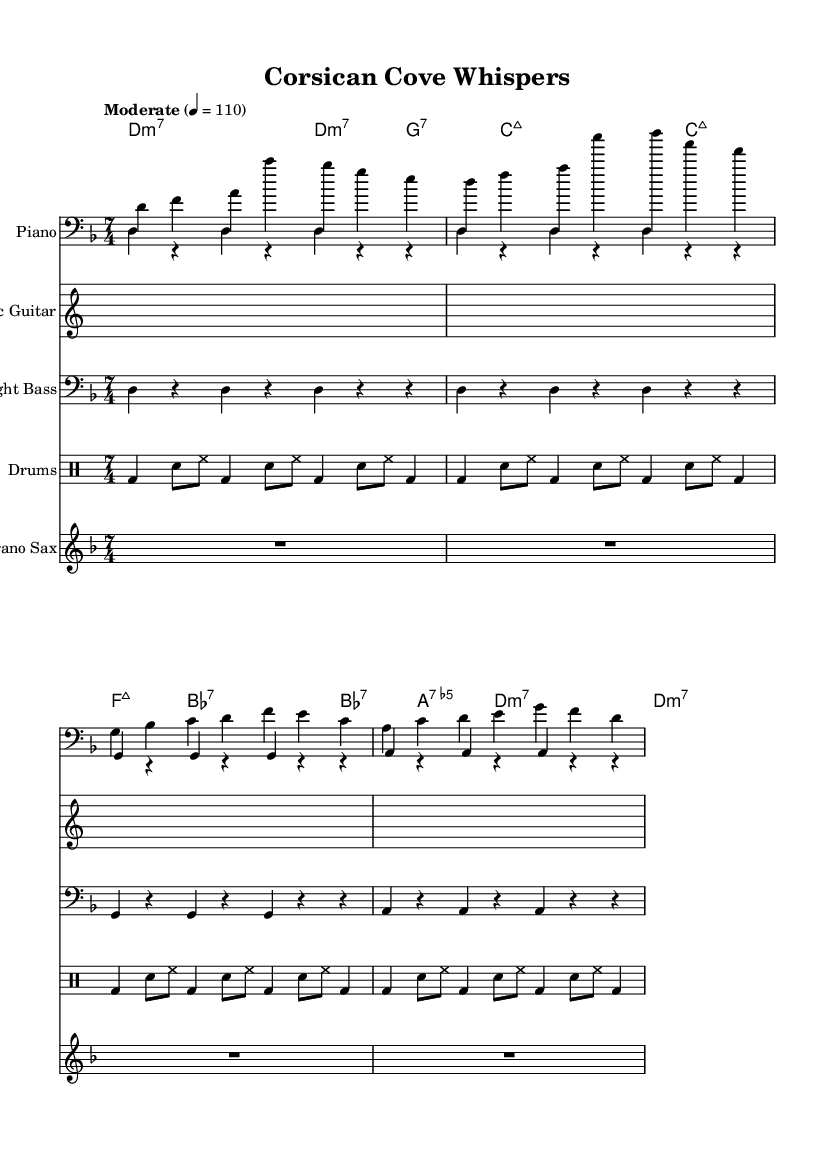What is the key signature of this music? The key signature is D minor, which has one flat (B flat). D minor is determined by the presence of the flat notated in the signature area before the time signature.
Answer: D minor What is the time signature of this music? The time signature is 7/4, which indicates there are seven beats in each measure and the quarter note gets one beat. This is confirmed by looking at the time signature indication in the sheet music.
Answer: 7/4 What is the tempo marking indicated in the music? The tempo marking is "Moderate" with a metronome setting of 110 beats per minute. This is shown in the tempo indication at the beginning of the score, specifying how fast the performance of the piece should be.
Answer: Moderate 4 = 110 How many measures are indicated for the piano right hand theme? There are two measures for the piano right hand theme, as shown by the notation of the mainTheme in the right-hand voice, which contains sequences of notes organized into two separate measures.
Answer: 2 Which instrument plays the bass line according to the sheet music? The upright bass plays the bass line, indicated by its separate staff that contains the bass clef notation. This is confirmed by the labeled staff within the score indicating the instrument.
Answer: Upright Bass What chord type appears most frequently in the chord names section? The chord type that appears most frequently is minor seventh (m7), as evidenced by the sequence of chords listed, where "d:m7" and "g:7" are part of a repeating structure.
Answer: m7 Which type of music does this piece represent? This piece represents jazz fusion, characterized by the progressive time signature, complex chord structures, and improvisational qualities typical of the genre. This understanding is gained by analyzing the overall style and arrangement present in the sheet music.
Answer: Jazz fusion 